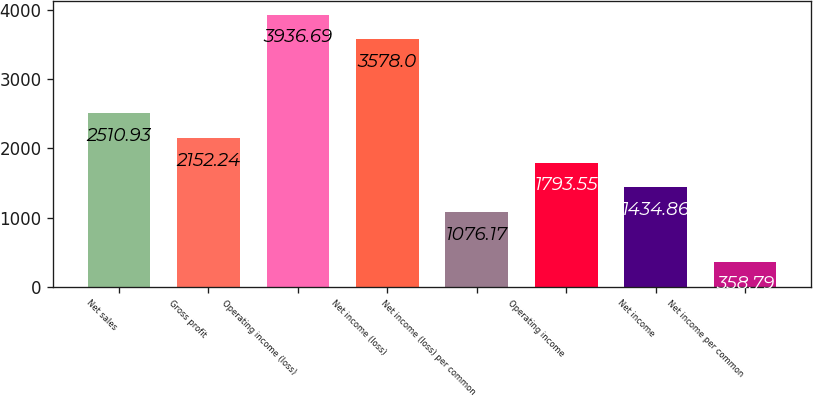Convert chart. <chart><loc_0><loc_0><loc_500><loc_500><bar_chart><fcel>Net sales<fcel>Gross profit<fcel>Operating income (loss)<fcel>Net income (loss)<fcel>Net income (loss) per common<fcel>Operating income<fcel>Net income<fcel>Net income per common<nl><fcel>2510.93<fcel>2152.24<fcel>3936.69<fcel>3578<fcel>1076.17<fcel>1793.55<fcel>1434.86<fcel>358.79<nl></chart> 